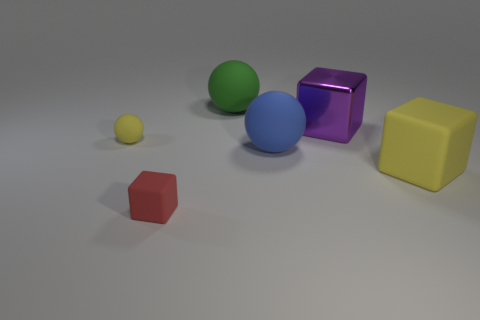How many things are purple metal spheres or blocks that are in front of the yellow matte block?
Provide a short and direct response. 1. There is a shiny block; does it have the same color as the large matte ball behind the yellow rubber ball?
Make the answer very short. No. There is a rubber sphere that is in front of the large green object and to the right of the red thing; what size is it?
Your answer should be very brief. Large. Are there any big yellow objects left of the green matte sphere?
Offer a terse response. No. There is a large ball that is in front of the big green object; are there any large rubber spheres behind it?
Ensure brevity in your answer.  Yes. Is the number of tiny yellow balls behind the big metal block the same as the number of green matte balls that are to the left of the green thing?
Offer a very short reply. Yes. There is a large cube that is the same material as the large green sphere; what is its color?
Your answer should be very brief. Yellow. Is there a small green ball that has the same material as the green thing?
Your answer should be compact. No. How many objects are either blue matte cylinders or big blue rubber objects?
Make the answer very short. 1. Are the red block and the yellow object that is in front of the tiny yellow matte thing made of the same material?
Provide a succinct answer. Yes. 